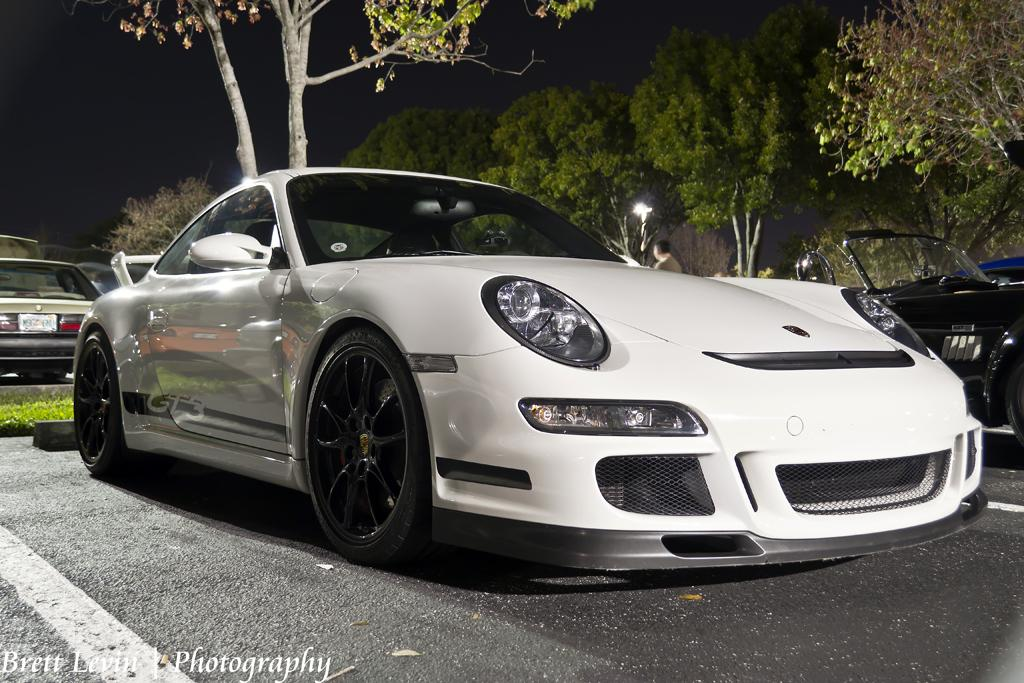What can be seen on the road in the image? There are vehicles on the road in the image. Can you describe the person in the image? There is a person in the image. What type of natural scenery is visible in the image? There are trees visible in the image. What type of guitar can be seen in the hands of the person in the image? There is no guitar present in the image; only vehicles, a person, and trees are visible. What type of cracker is being used to view the image? The image is not being viewed through a cracker; it is a digital image or a physical photograph. 